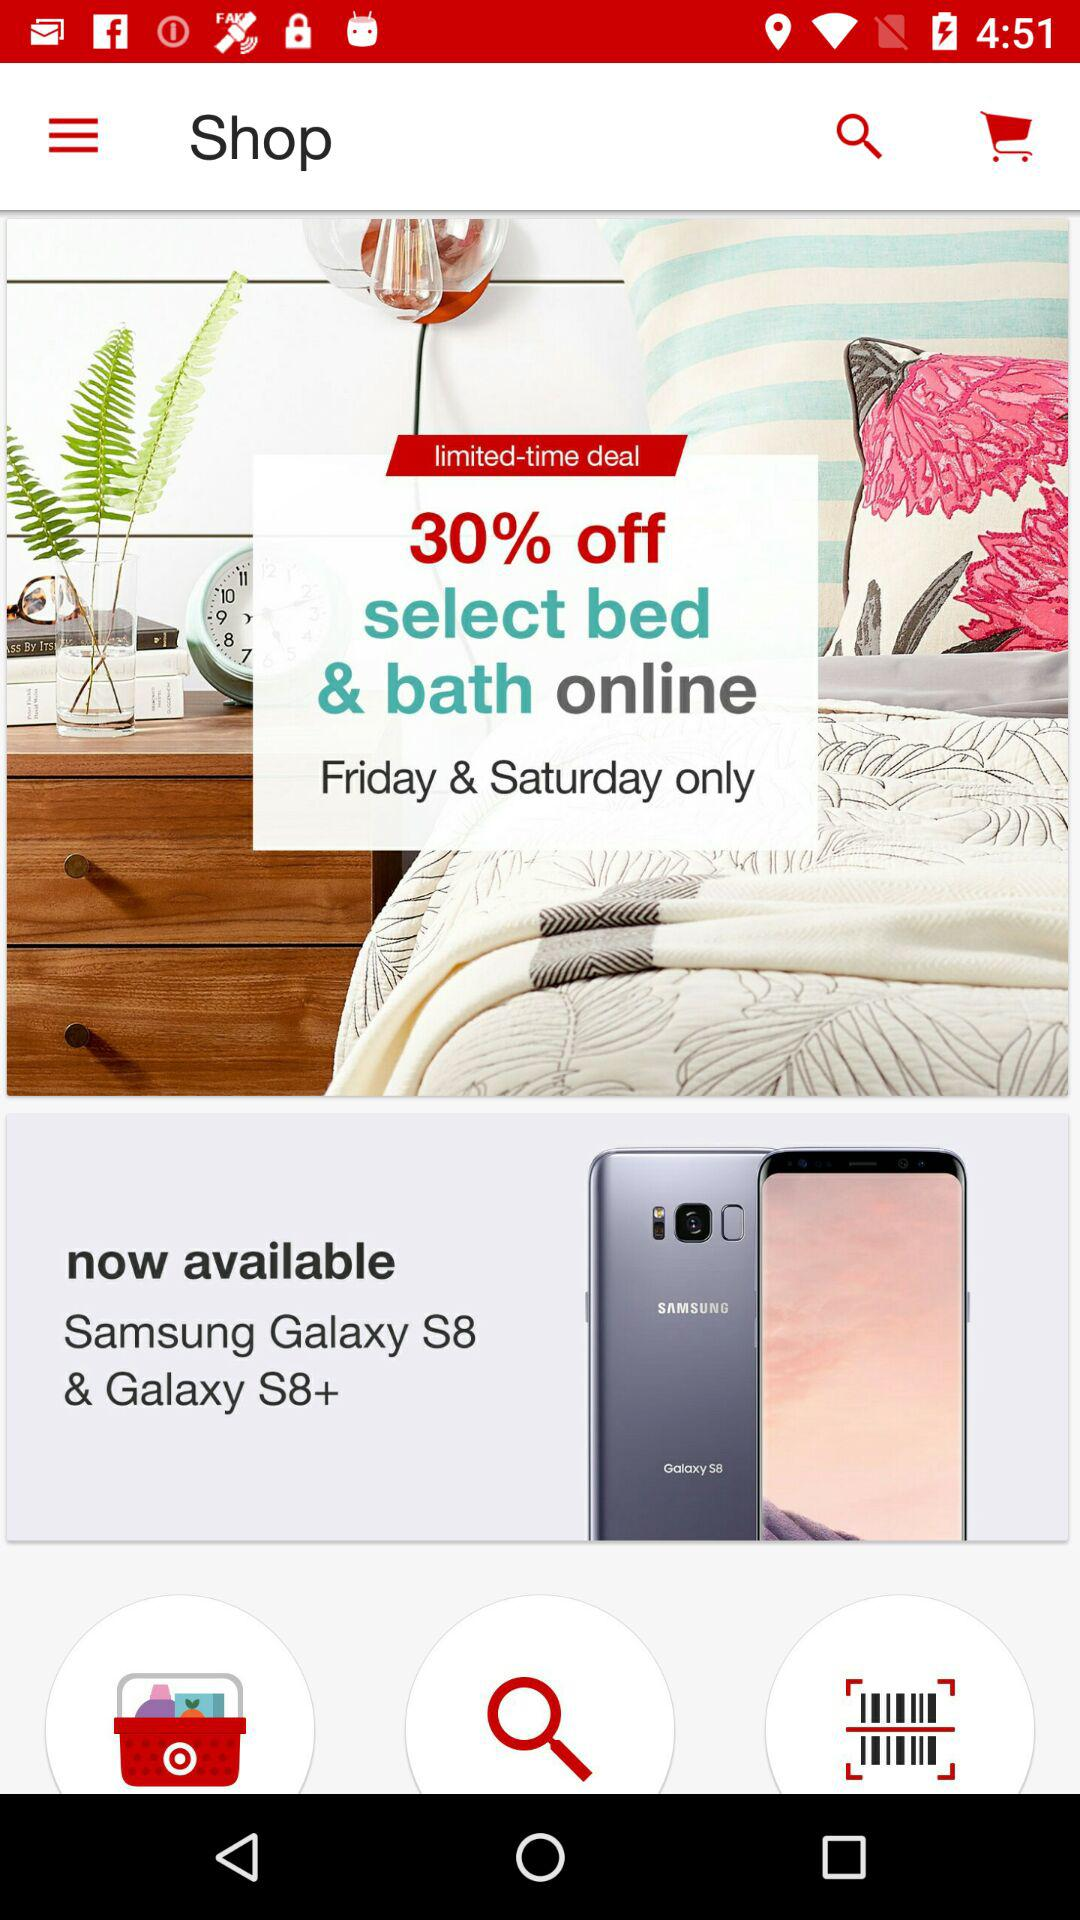On which days 30% off is applicable? It is applicable on Friday and Saturday. 